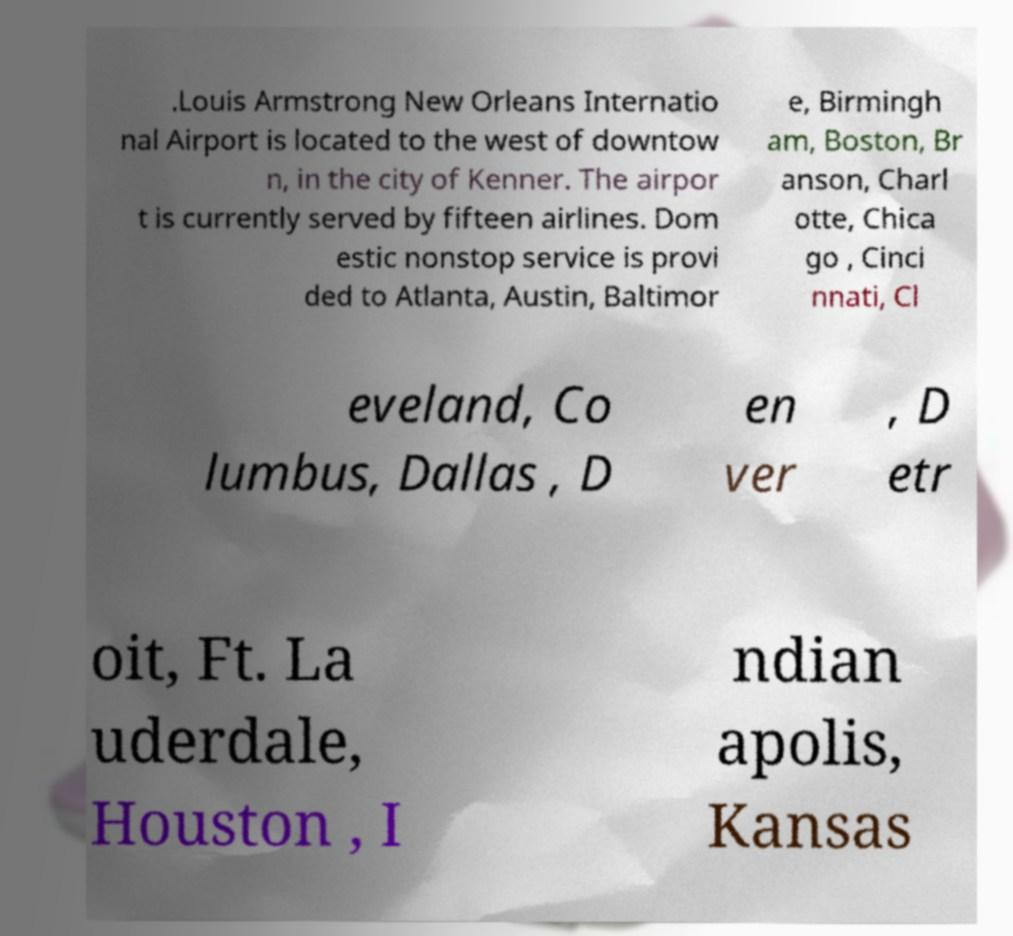Could you assist in decoding the text presented in this image and type it out clearly? .Louis Armstrong New Orleans Internatio nal Airport is located to the west of downtow n, in the city of Kenner. The airpor t is currently served by fifteen airlines. Dom estic nonstop service is provi ded to Atlanta, Austin, Baltimor e, Birmingh am, Boston, Br anson, Charl otte, Chica go , Cinci nnati, Cl eveland, Co lumbus, Dallas , D en ver , D etr oit, Ft. La uderdale, Houston , I ndian apolis, Kansas 